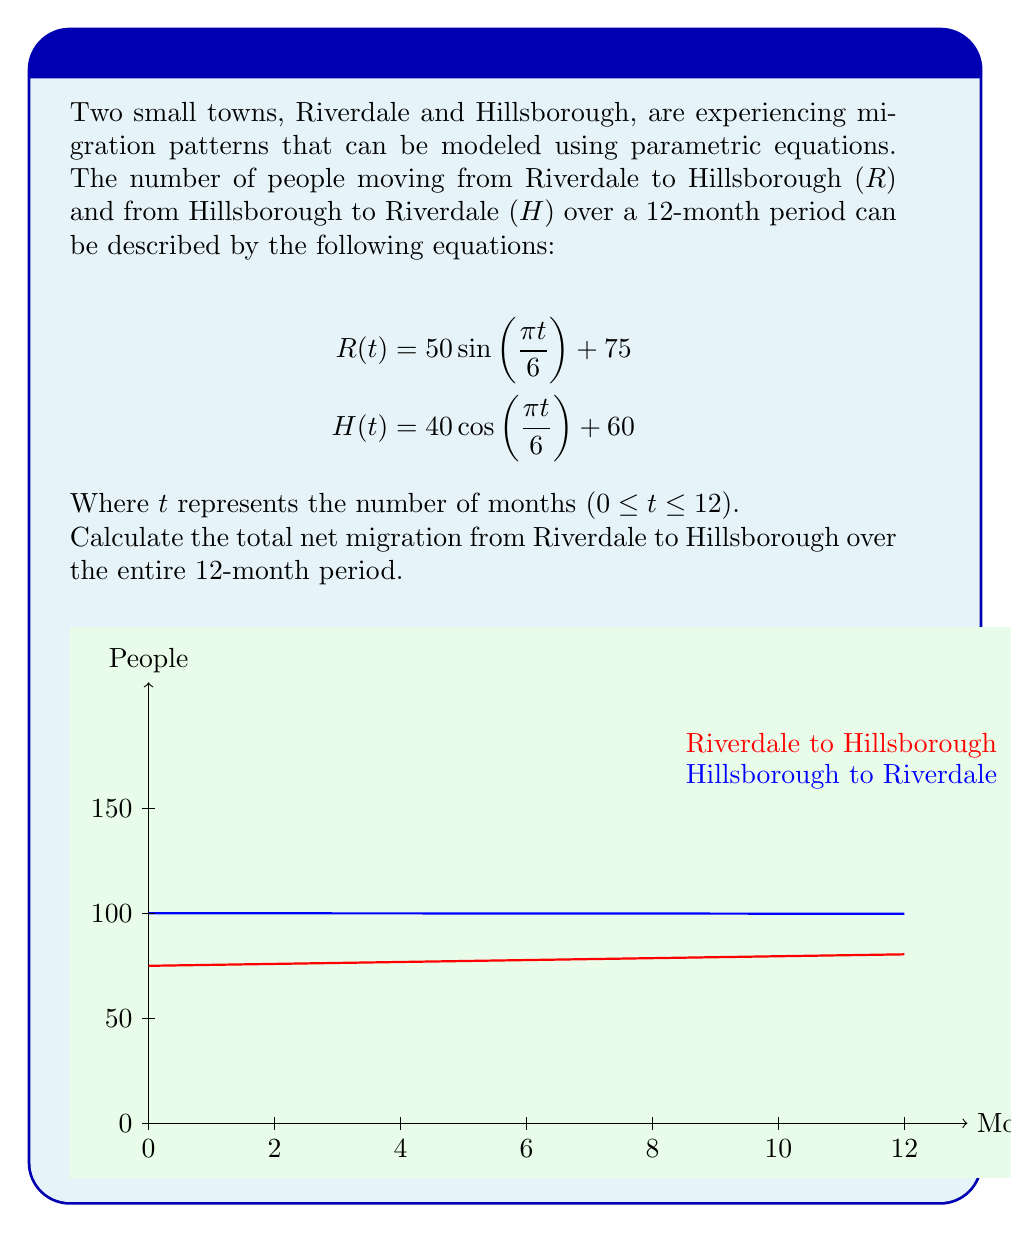Solve this math problem. To solve this problem, we need to follow these steps:

1) First, we need to find the total number of people moving from Riverdale to Hillsborough over 12 months. This can be done by integrating R(t) from 0 to 12:

   $$\int_0^{12} R(t) dt = \int_0^{12} (50 \sin(\frac{\pi t}{6}) + 75) dt$$

2) Similarly, we need to find the total number of people moving from Hillsborough to Riverdale:

   $$\int_0^{12} H(t) dt = \int_0^{12} (40 \cos(\frac{\pi t}{6}) + 60) dt$$

3) Let's solve these integrals:

   For R(t):
   $$\int_0^{12} (50 \sin(\frac{\pi t}{6}) + 75) dt = [-300 \cos(\frac{\pi t}{6}) + 75t]_0^{12} = (-300 \cos(2\pi) + 900) - (-300 + 0) = 1200$$

   For H(t):
   $$\int_0^{12} (40 \cos(\frac{\pi t}{6}) + 60) dt = [240 \sin(\frac{\pi t}{6}) + 60t]_0^{12} = (0 + 720) - (0 + 0) = 720$$

4) The net migration from Riverdale to Hillsborough is the difference between these two values:

   Net migration = 1200 - 720 = 480

Therefore, over the 12-month period, there is a net migration of 480 people from Riverdale to Hillsborough.
Answer: 480 people 